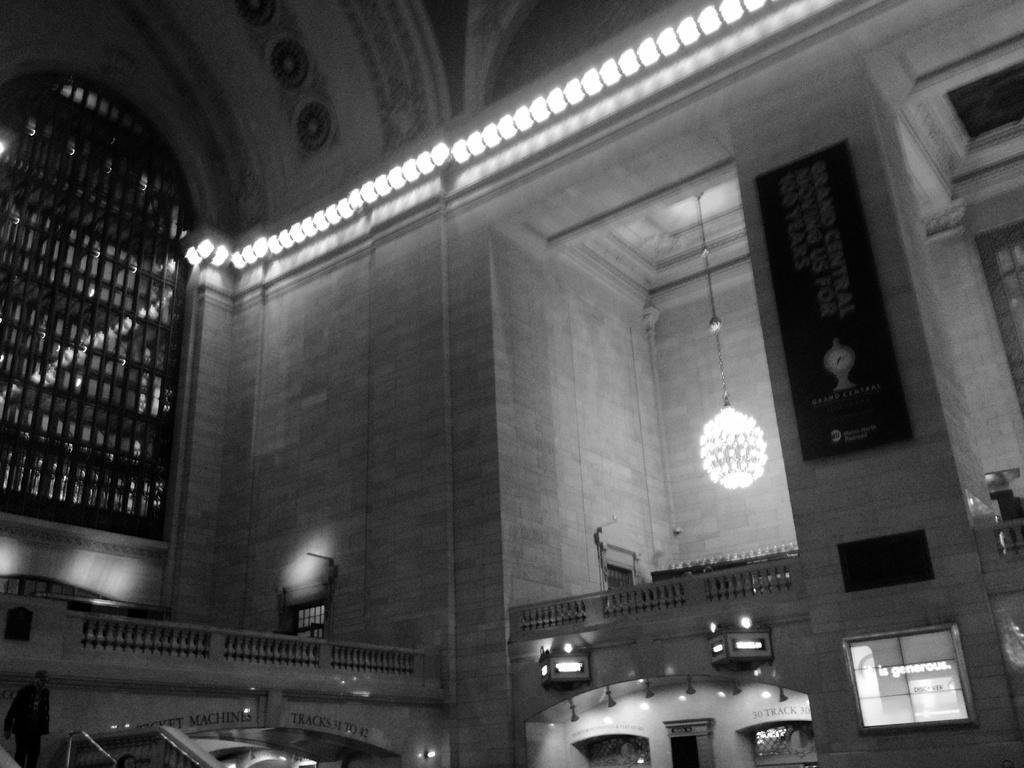Can you describe this image briefly? It is an inside view of the house. Here we can see walls, chandelier with chain, banner, railings, lights, glass windows, grill. Top of the image, there is a roof. Left side bottom corner, we can see a person. 